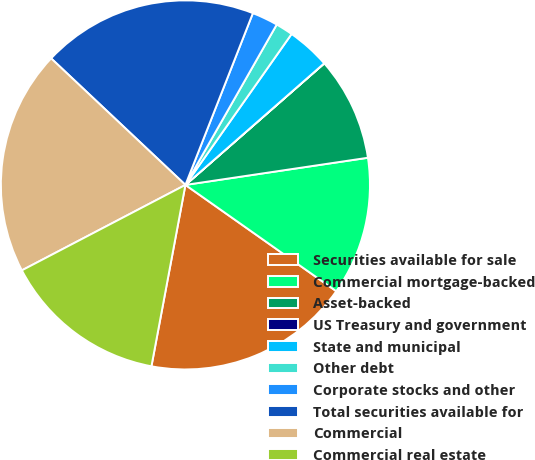Convert chart to OTSL. <chart><loc_0><loc_0><loc_500><loc_500><pie_chart><fcel>Securities available for sale<fcel>Commercial mortgage-backed<fcel>Asset-backed<fcel>US Treasury and government<fcel>State and municipal<fcel>Other debt<fcel>Corporate stocks and other<fcel>Total securities available for<fcel>Commercial<fcel>Commercial real estate<nl><fcel>18.18%<fcel>12.12%<fcel>9.09%<fcel>0.01%<fcel>3.79%<fcel>1.52%<fcel>2.28%<fcel>18.93%<fcel>19.69%<fcel>14.39%<nl></chart> 